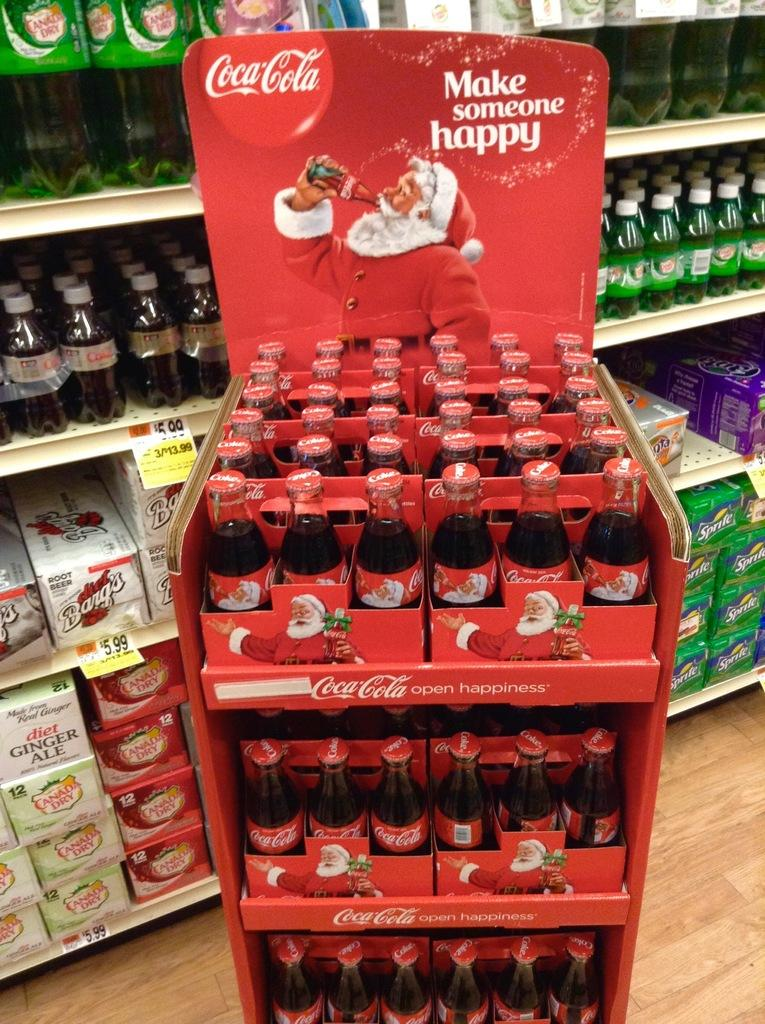What type of items can be seen in the image? There are bottles of drinks in the image. Where are the bottles of drinks located? The bottles of drinks are on the aisles. What type of fruit is present in the image? There is no fruit present in the image; it only features bottles of drinks on the aisles. 